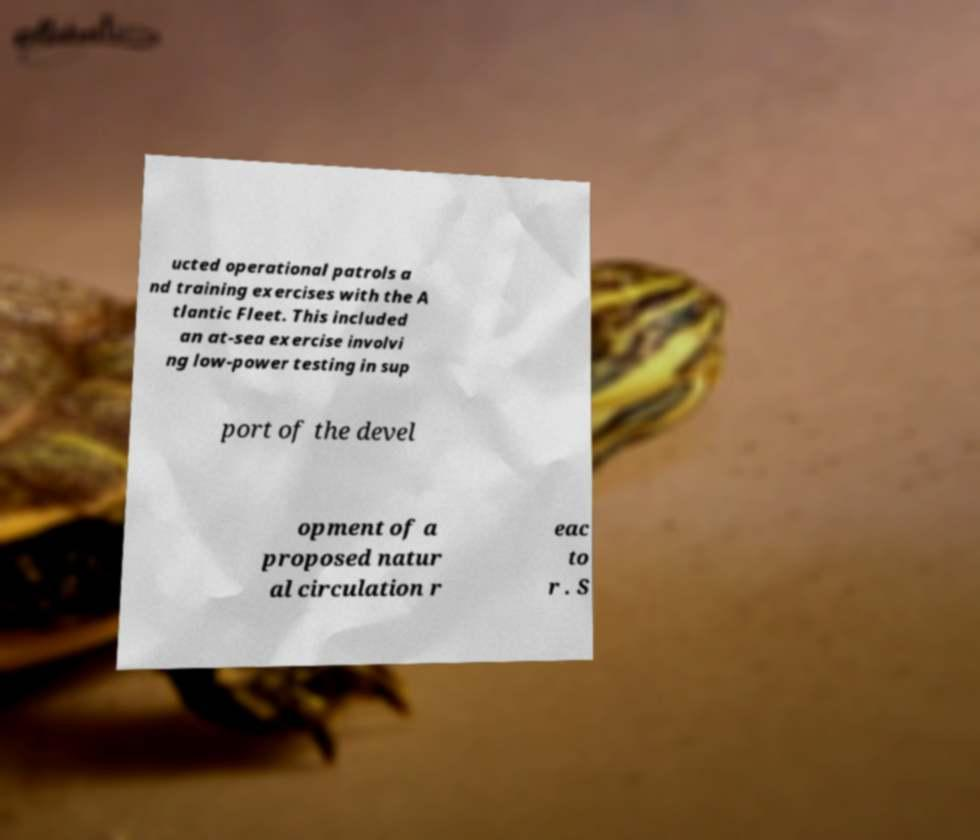Could you assist in decoding the text presented in this image and type it out clearly? ucted operational patrols a nd training exercises with the A tlantic Fleet. This included an at-sea exercise involvi ng low-power testing in sup port of the devel opment of a proposed natur al circulation r eac to r . S 